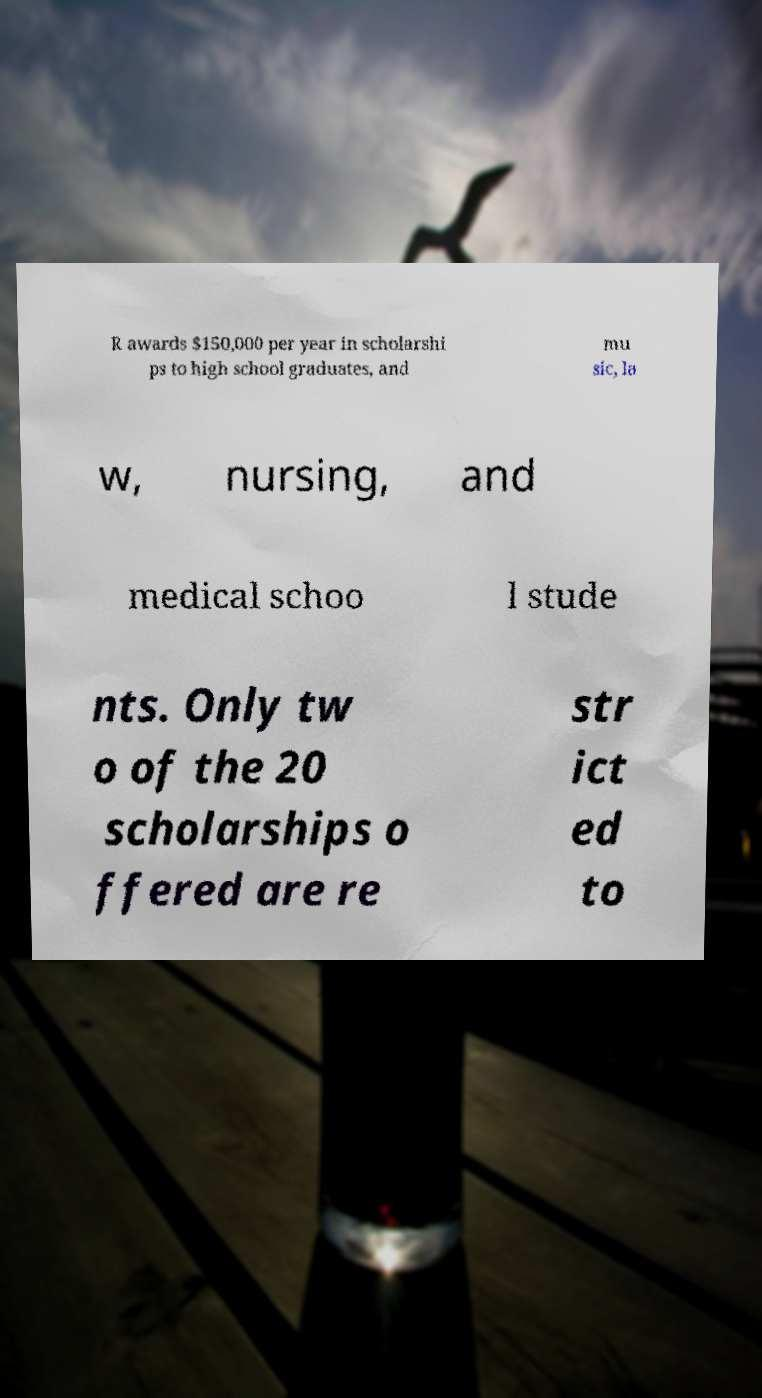Can you read and provide the text displayed in the image?This photo seems to have some interesting text. Can you extract and type it out for me? R awards $150,000 per year in scholarshi ps to high school graduates, and mu sic, la w, nursing, and medical schoo l stude nts. Only tw o of the 20 scholarships o ffered are re str ict ed to 